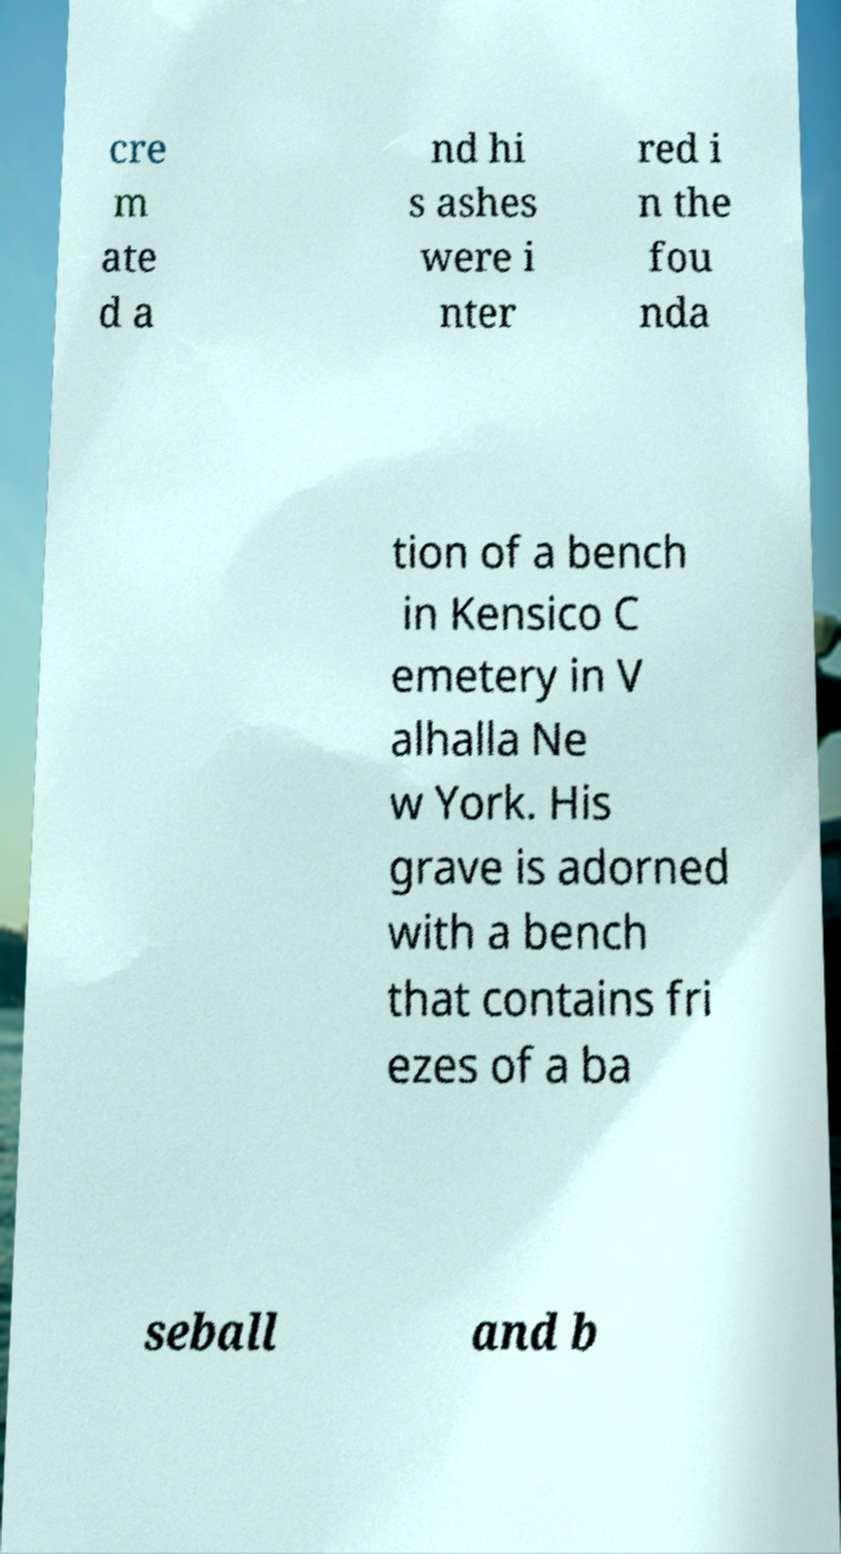Can you accurately transcribe the text from the provided image for me? cre m ate d a nd hi s ashes were i nter red i n the fou nda tion of a bench in Kensico C emetery in V alhalla Ne w York. His grave is adorned with a bench that contains fri ezes of a ba seball and b 